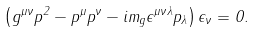<formula> <loc_0><loc_0><loc_500><loc_500>\left ( { g } ^ { \mu \nu } p ^ { 2 } - p ^ { \mu } p ^ { \nu } - i m _ { g } \epsilon ^ { \mu \nu \lambda } p _ { \lambda } \right ) \epsilon _ { \nu } = 0 .</formula> 